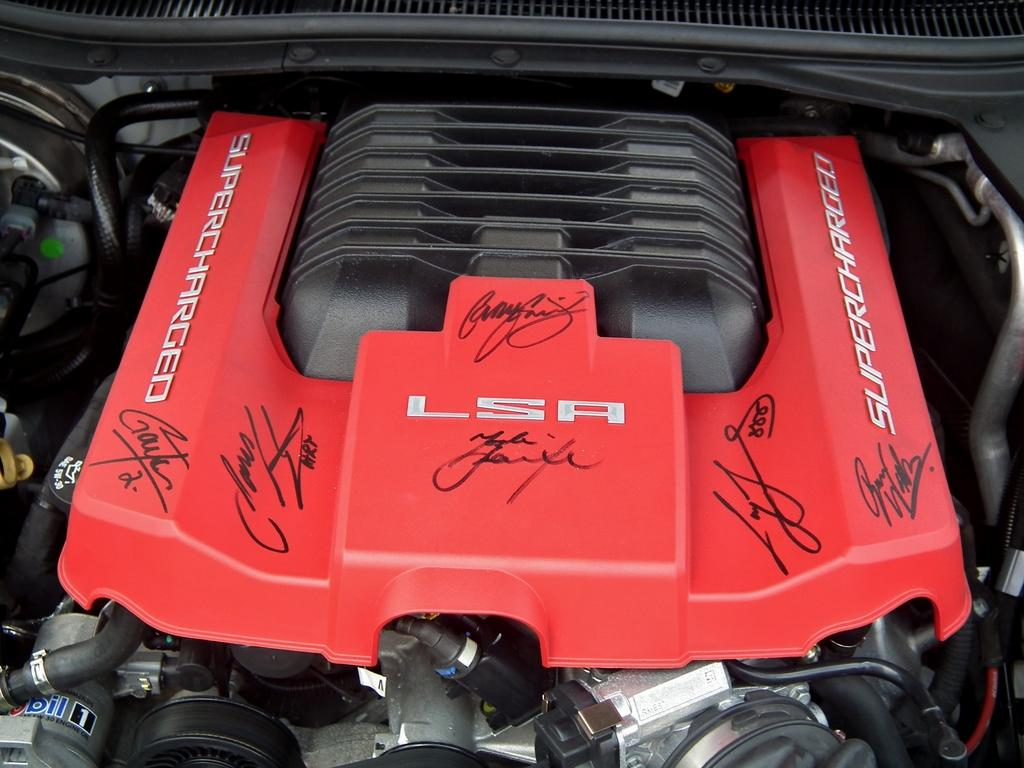What is the main subject of the image? The main subject of the image is a car engine. What colors are present in the car engine? The car engine has red and black colors. What type of components can be seen in the image? There are wires visible in the image, as well as other unspecified components. Where is the soap placed in the image? There is no soap present in the image. Can you tell me how many goats are visible in the image? There are no goats visible in the image. 